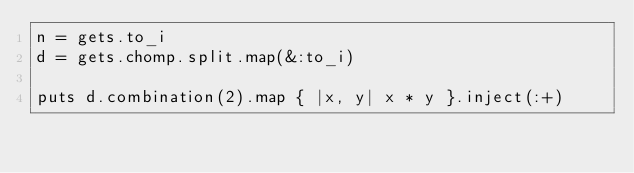<code> <loc_0><loc_0><loc_500><loc_500><_Ruby_>n = gets.to_i
d = gets.chomp.split.map(&:to_i)

puts d.combination(2).map { |x, y| x * y }.inject(:+)</code> 